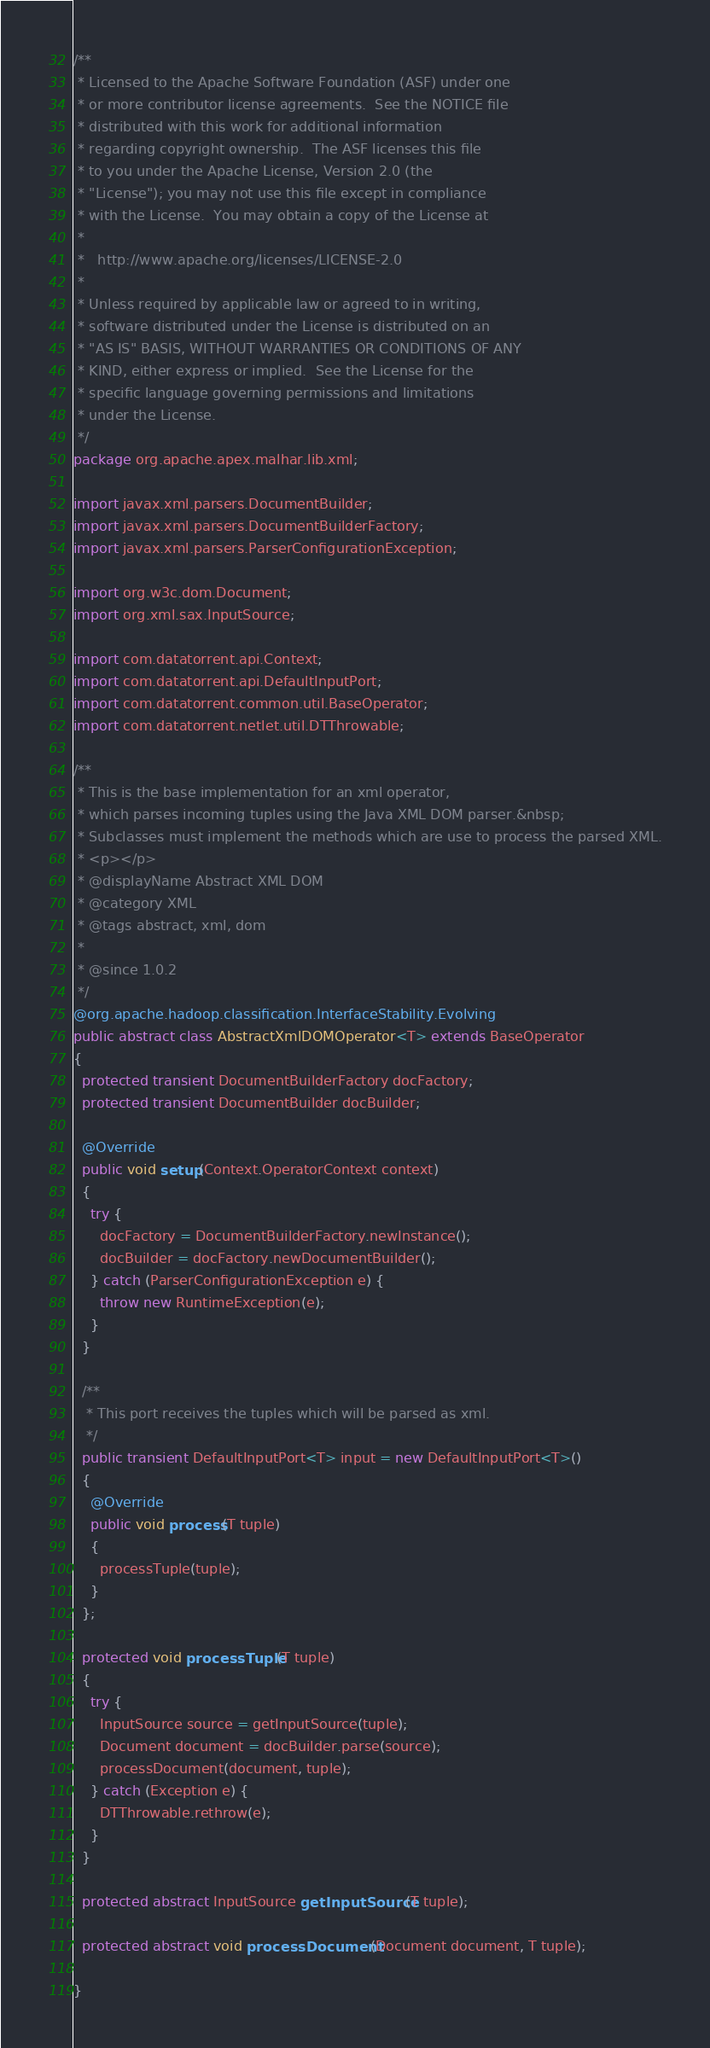<code> <loc_0><loc_0><loc_500><loc_500><_Java_>/**
 * Licensed to the Apache Software Foundation (ASF) under one
 * or more contributor license agreements.  See the NOTICE file
 * distributed with this work for additional information
 * regarding copyright ownership.  The ASF licenses this file
 * to you under the Apache License, Version 2.0 (the
 * "License"); you may not use this file except in compliance
 * with the License.  You may obtain a copy of the License at
 *
 *   http://www.apache.org/licenses/LICENSE-2.0
 *
 * Unless required by applicable law or agreed to in writing,
 * software distributed under the License is distributed on an
 * "AS IS" BASIS, WITHOUT WARRANTIES OR CONDITIONS OF ANY
 * KIND, either express or implied.  See the License for the
 * specific language governing permissions and limitations
 * under the License.
 */
package org.apache.apex.malhar.lib.xml;

import javax.xml.parsers.DocumentBuilder;
import javax.xml.parsers.DocumentBuilderFactory;
import javax.xml.parsers.ParserConfigurationException;

import org.w3c.dom.Document;
import org.xml.sax.InputSource;

import com.datatorrent.api.Context;
import com.datatorrent.api.DefaultInputPort;
import com.datatorrent.common.util.BaseOperator;
import com.datatorrent.netlet.util.DTThrowable;

/**
 * This is the base implementation for an xml operator,
 * which parses incoming tuples using the Java XML DOM parser.&nbsp;
 * Subclasses must implement the methods which are use to process the parsed XML.
 * <p></p>
 * @displayName Abstract XML DOM
 * @category XML
 * @tags abstract, xml, dom
 *
 * @since 1.0.2
 */
@org.apache.hadoop.classification.InterfaceStability.Evolving
public abstract class AbstractXmlDOMOperator<T> extends BaseOperator
{
  protected transient DocumentBuilderFactory docFactory;
  protected transient DocumentBuilder docBuilder;

  @Override
  public void setup(Context.OperatorContext context)
  {
    try {
      docFactory = DocumentBuilderFactory.newInstance();
      docBuilder = docFactory.newDocumentBuilder();
    } catch (ParserConfigurationException e) {
      throw new RuntimeException(e);
    }
  }

  /**
   * This port receives the tuples which will be parsed as xml.
   */
  public transient DefaultInputPort<T> input = new DefaultInputPort<T>()
  {
    @Override
    public void process(T tuple)
    {
      processTuple(tuple);
    }
  };

  protected void processTuple(T tuple)
  {
    try {
      InputSource source = getInputSource(tuple);
      Document document = docBuilder.parse(source);
      processDocument(document, tuple);
    } catch (Exception e) {
      DTThrowable.rethrow(e);
    }
  }

  protected abstract InputSource getInputSource(T tuple);

  protected abstract void processDocument(Document document, T tuple);

}
</code> 